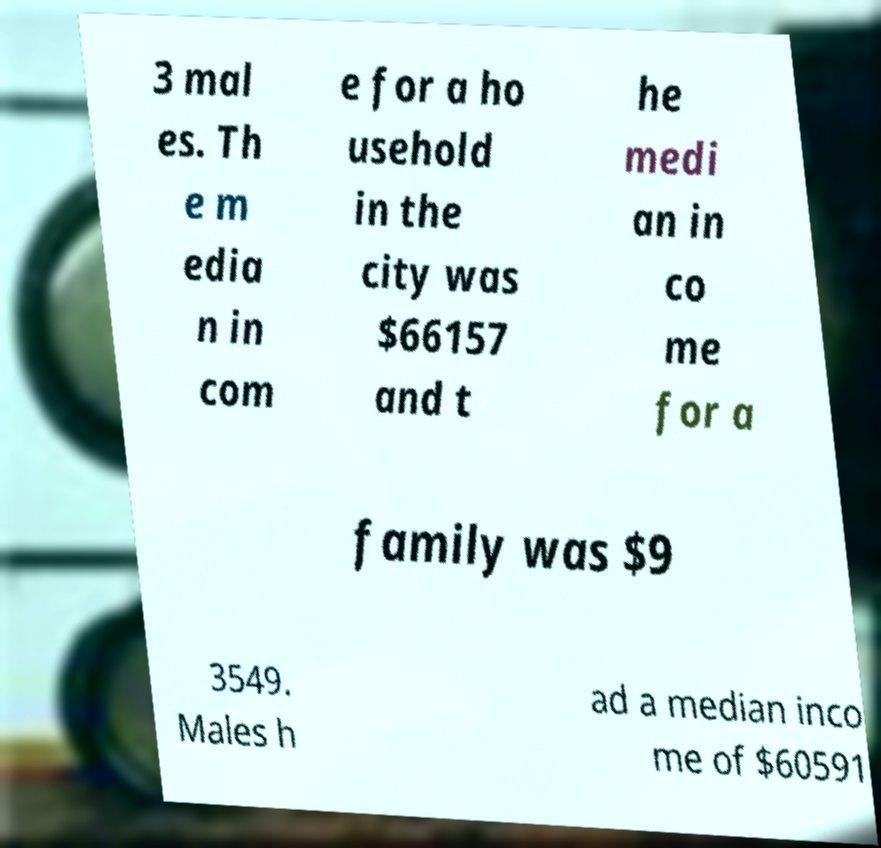What messages or text are displayed in this image? I need them in a readable, typed format. 3 mal es. Th e m edia n in com e for a ho usehold in the city was $66157 and t he medi an in co me for a family was $9 3549. Males h ad a median inco me of $60591 